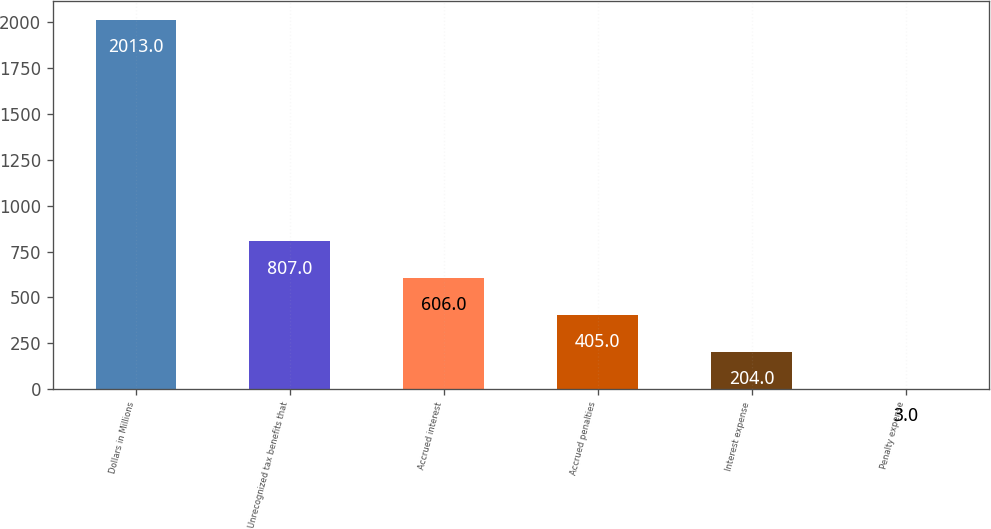Convert chart to OTSL. <chart><loc_0><loc_0><loc_500><loc_500><bar_chart><fcel>Dollars in Millions<fcel>Unrecognized tax benefits that<fcel>Accrued interest<fcel>Accrued penalties<fcel>Interest expense<fcel>Penalty expense<nl><fcel>2013<fcel>807<fcel>606<fcel>405<fcel>204<fcel>3<nl></chart> 